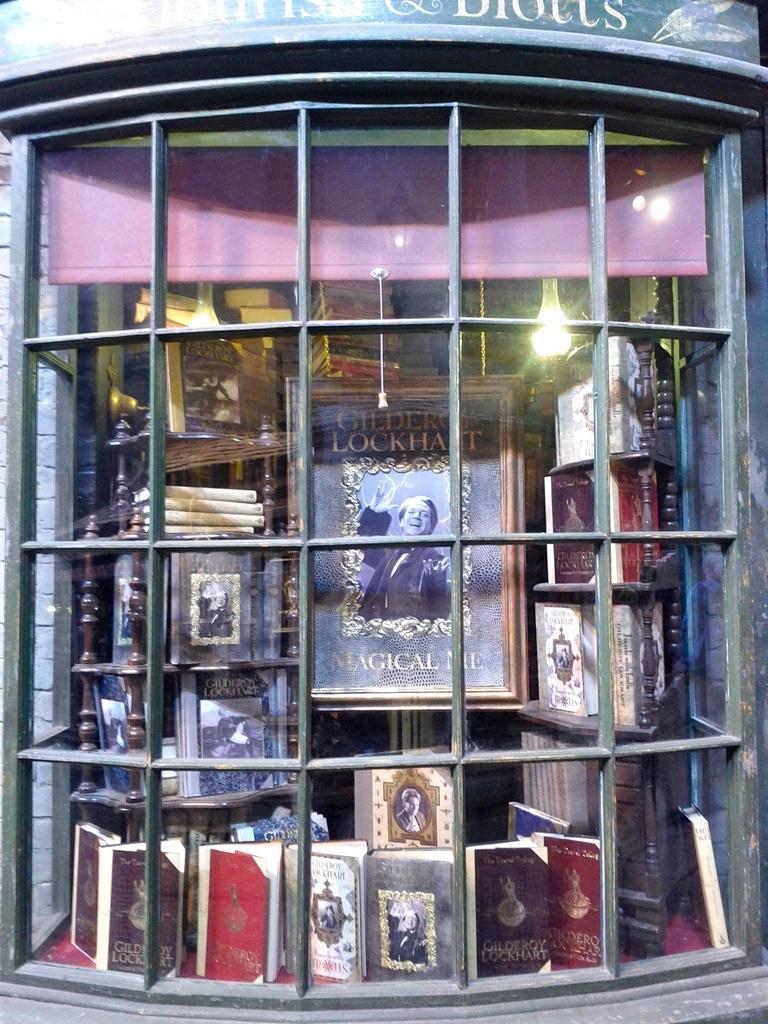Describe this image in one or two sentences. In this image, we can see a metal grills. In the background, we can see some books and a photo frame. 